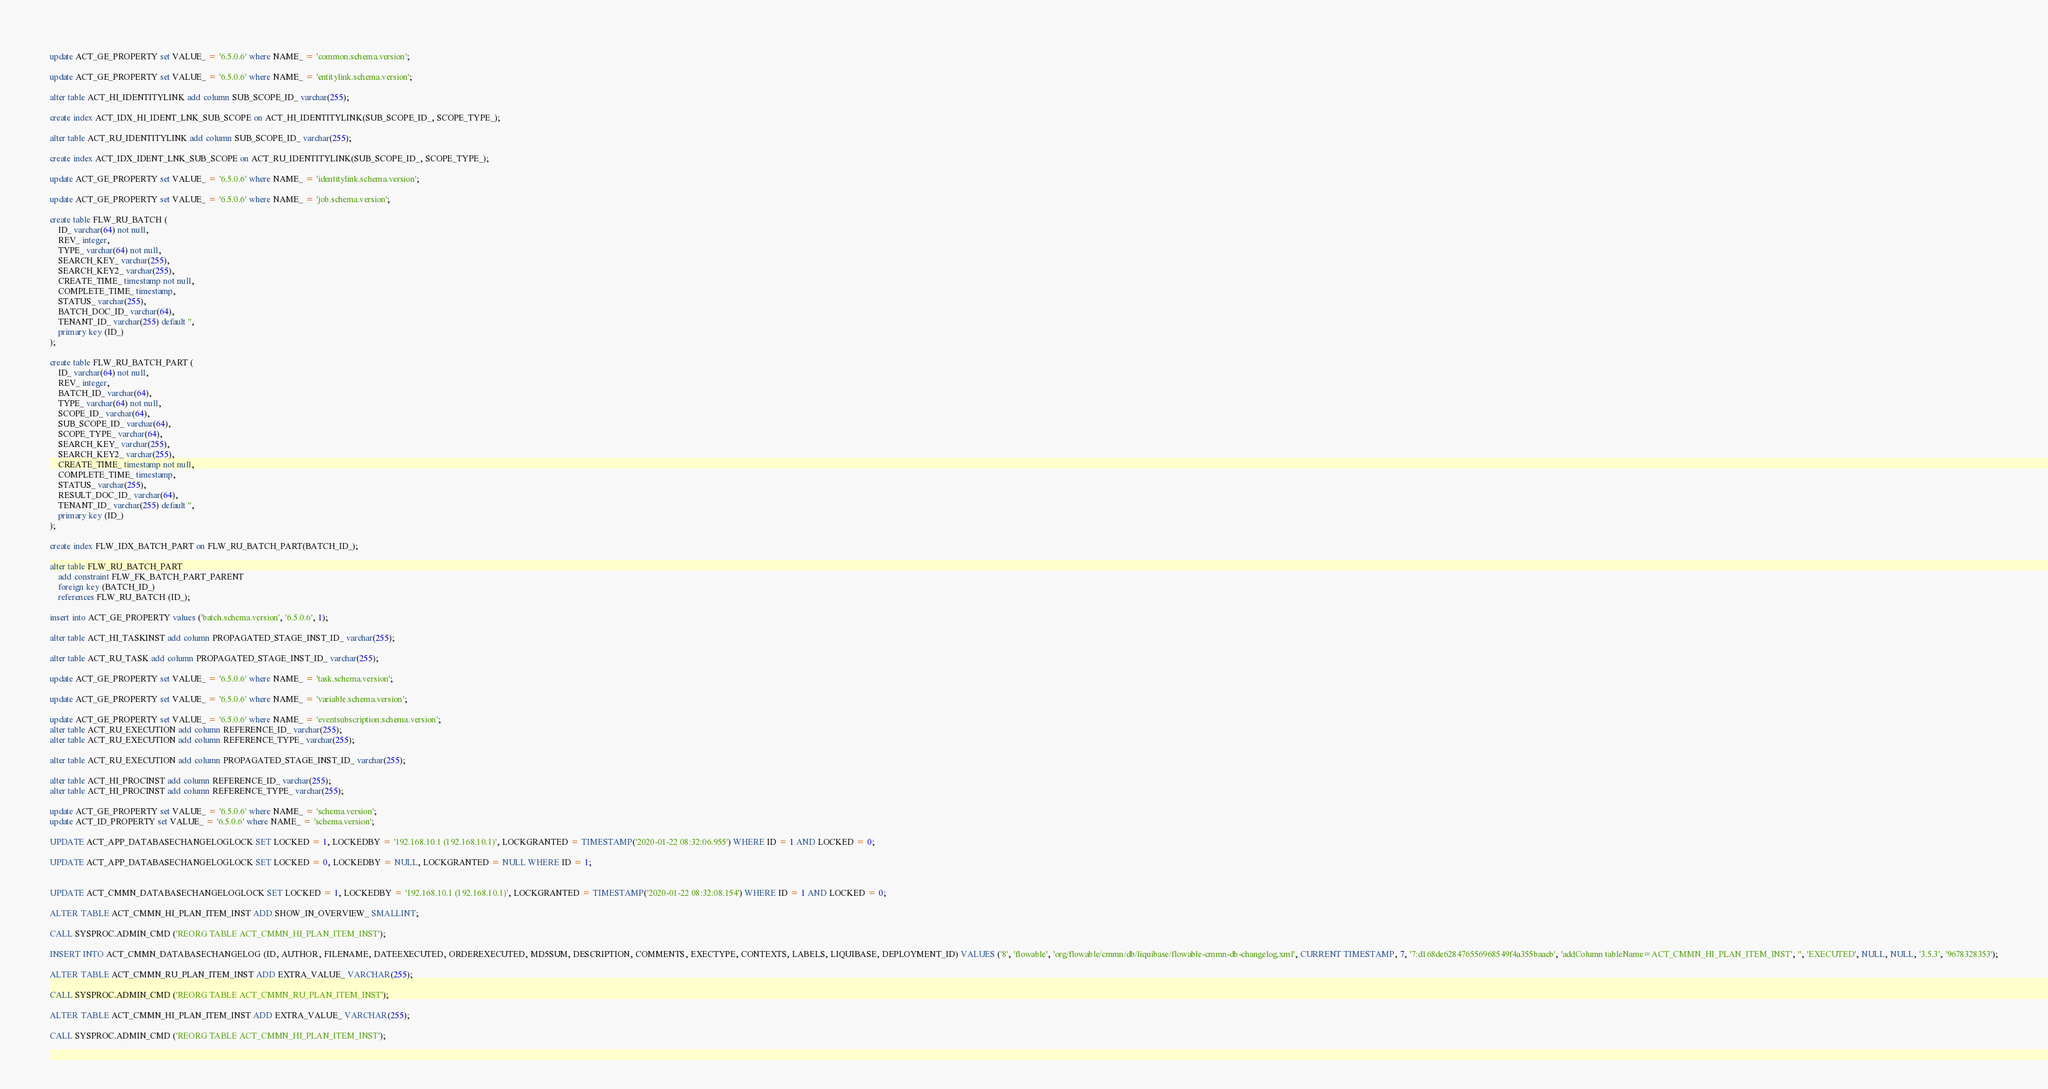Convert code to text. <code><loc_0><loc_0><loc_500><loc_500><_SQL_>update ACT_GE_PROPERTY set VALUE_ = '6.5.0.6' where NAME_ = 'common.schema.version';

update ACT_GE_PROPERTY set VALUE_ = '6.5.0.6' where NAME_ = 'entitylink.schema.version';

alter table ACT_HI_IDENTITYLINK add column SUB_SCOPE_ID_ varchar(255);

create index ACT_IDX_HI_IDENT_LNK_SUB_SCOPE on ACT_HI_IDENTITYLINK(SUB_SCOPE_ID_, SCOPE_TYPE_);

alter table ACT_RU_IDENTITYLINK add column SUB_SCOPE_ID_ varchar(255);

create index ACT_IDX_IDENT_LNK_SUB_SCOPE on ACT_RU_IDENTITYLINK(SUB_SCOPE_ID_, SCOPE_TYPE_);

update ACT_GE_PROPERTY set VALUE_ = '6.5.0.6' where NAME_ = 'identitylink.schema.version';

update ACT_GE_PROPERTY set VALUE_ = '6.5.0.6' where NAME_ = 'job.schema.version';

create table FLW_RU_BATCH (
    ID_ varchar(64) not null,
    REV_ integer,
    TYPE_ varchar(64) not null,
    SEARCH_KEY_ varchar(255),
    SEARCH_KEY2_ varchar(255),
    CREATE_TIME_ timestamp not null,
    COMPLETE_TIME_ timestamp,
    STATUS_ varchar(255),
    BATCH_DOC_ID_ varchar(64),
    TENANT_ID_ varchar(255) default '',
    primary key (ID_)
);

create table FLW_RU_BATCH_PART (
    ID_ varchar(64) not null,
    REV_ integer,
    BATCH_ID_ varchar(64),
    TYPE_ varchar(64) not null,
    SCOPE_ID_ varchar(64),
    SUB_SCOPE_ID_ varchar(64),
    SCOPE_TYPE_ varchar(64),
    SEARCH_KEY_ varchar(255),
    SEARCH_KEY2_ varchar(255),
    CREATE_TIME_ timestamp not null,
    COMPLETE_TIME_ timestamp,
    STATUS_ varchar(255),
    RESULT_DOC_ID_ varchar(64),
    TENANT_ID_ varchar(255) default '',
    primary key (ID_)
);

create index FLW_IDX_BATCH_PART on FLW_RU_BATCH_PART(BATCH_ID_);

alter table FLW_RU_BATCH_PART
    add constraint FLW_FK_BATCH_PART_PARENT
    foreign key (BATCH_ID_)
    references FLW_RU_BATCH (ID_);

insert into ACT_GE_PROPERTY values ('batch.schema.version', '6.5.0.6', 1);

alter table ACT_HI_TASKINST add column PROPAGATED_STAGE_INST_ID_ varchar(255);

alter table ACT_RU_TASK add column PROPAGATED_STAGE_INST_ID_ varchar(255);

update ACT_GE_PROPERTY set VALUE_ = '6.5.0.6' where NAME_ = 'task.schema.version';

update ACT_GE_PROPERTY set VALUE_ = '6.5.0.6' where NAME_ = 'variable.schema.version';

update ACT_GE_PROPERTY set VALUE_ = '6.5.0.6' where NAME_ = 'eventsubscription.schema.version';
alter table ACT_RU_EXECUTION add column REFERENCE_ID_ varchar(255);
alter table ACT_RU_EXECUTION add column REFERENCE_TYPE_ varchar(255);

alter table ACT_RU_EXECUTION add column PROPAGATED_STAGE_INST_ID_ varchar(255);

alter table ACT_HI_PROCINST add column REFERENCE_ID_ varchar(255);
alter table ACT_HI_PROCINST add column REFERENCE_TYPE_ varchar(255);

update ACT_GE_PROPERTY set VALUE_ = '6.5.0.6' where NAME_ = 'schema.version';
update ACT_ID_PROPERTY set VALUE_ = '6.5.0.6' where NAME_ = 'schema.version';

UPDATE ACT_APP_DATABASECHANGELOGLOCK SET LOCKED = 1, LOCKEDBY = '192.168.10.1 (192.168.10.1)', LOCKGRANTED = TIMESTAMP('2020-01-22 08:32:06.955') WHERE ID = 1 AND LOCKED = 0;

UPDATE ACT_APP_DATABASECHANGELOGLOCK SET LOCKED = 0, LOCKEDBY = NULL, LOCKGRANTED = NULL WHERE ID = 1;


UPDATE ACT_CMMN_DATABASECHANGELOGLOCK SET LOCKED = 1, LOCKEDBY = '192.168.10.1 (192.168.10.1)', LOCKGRANTED = TIMESTAMP('2020-01-22 08:32:08.154') WHERE ID = 1 AND LOCKED = 0;

ALTER TABLE ACT_CMMN_HI_PLAN_ITEM_INST ADD SHOW_IN_OVERVIEW_ SMALLINT;

CALL SYSPROC.ADMIN_CMD ('REORG TABLE ACT_CMMN_HI_PLAN_ITEM_INST');

INSERT INTO ACT_CMMN_DATABASECHANGELOG (ID, AUTHOR, FILENAME, DATEEXECUTED, ORDEREXECUTED, MD5SUM, DESCRIPTION, COMMENTS, EXECTYPE, CONTEXTS, LABELS, LIQUIBASE, DEPLOYMENT_ID) VALUES ('8', 'flowable', 'org/flowable/cmmn/db/liquibase/flowable-cmmn-db-changelog.xml', CURRENT TIMESTAMP, 7, '7:d168de628476556968549f4a355baacb', 'addColumn tableName=ACT_CMMN_HI_PLAN_ITEM_INST', '', 'EXECUTED', NULL, NULL, '3.5.3', '9678328353');

ALTER TABLE ACT_CMMN_RU_PLAN_ITEM_INST ADD EXTRA_VALUE_ VARCHAR(255);

CALL SYSPROC.ADMIN_CMD ('REORG TABLE ACT_CMMN_RU_PLAN_ITEM_INST');

ALTER TABLE ACT_CMMN_HI_PLAN_ITEM_INST ADD EXTRA_VALUE_ VARCHAR(255);

CALL SYSPROC.ADMIN_CMD ('REORG TABLE ACT_CMMN_HI_PLAN_ITEM_INST');
</code> 